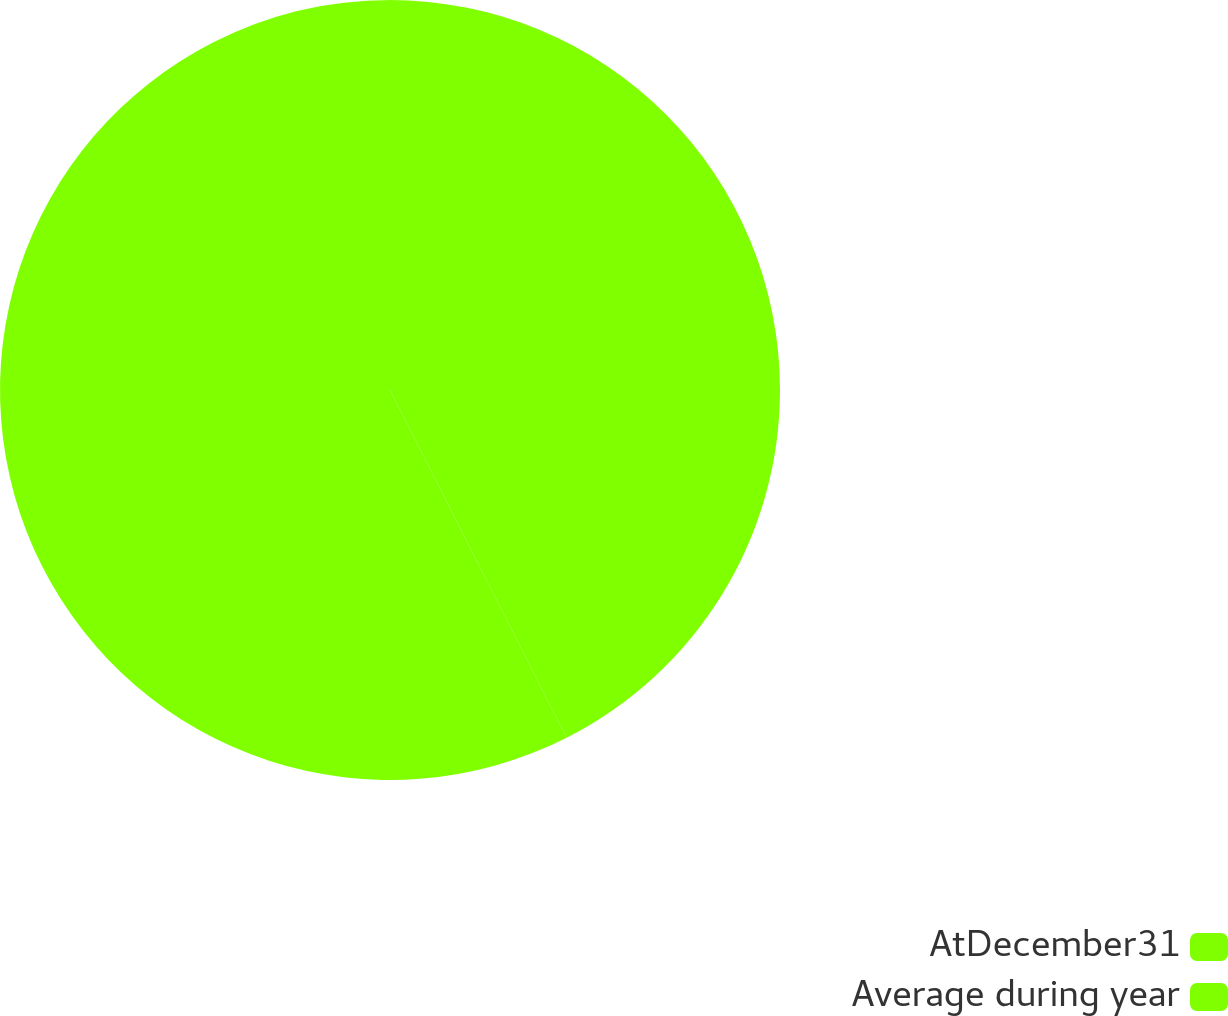Convert chart. <chart><loc_0><loc_0><loc_500><loc_500><pie_chart><fcel>AtDecember31<fcel>Average during year<nl><fcel>42.52%<fcel>57.48%<nl></chart> 